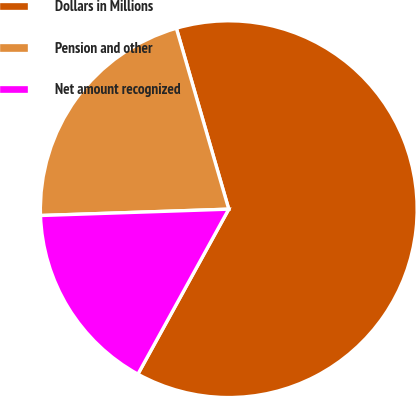<chart> <loc_0><loc_0><loc_500><loc_500><pie_chart><fcel>Dollars in Millions<fcel>Pension and other<fcel>Net amount recognized<nl><fcel>62.5%<fcel>21.05%<fcel>16.45%<nl></chart> 